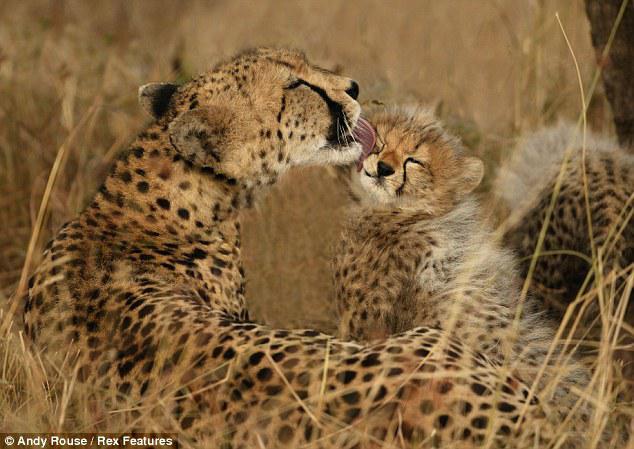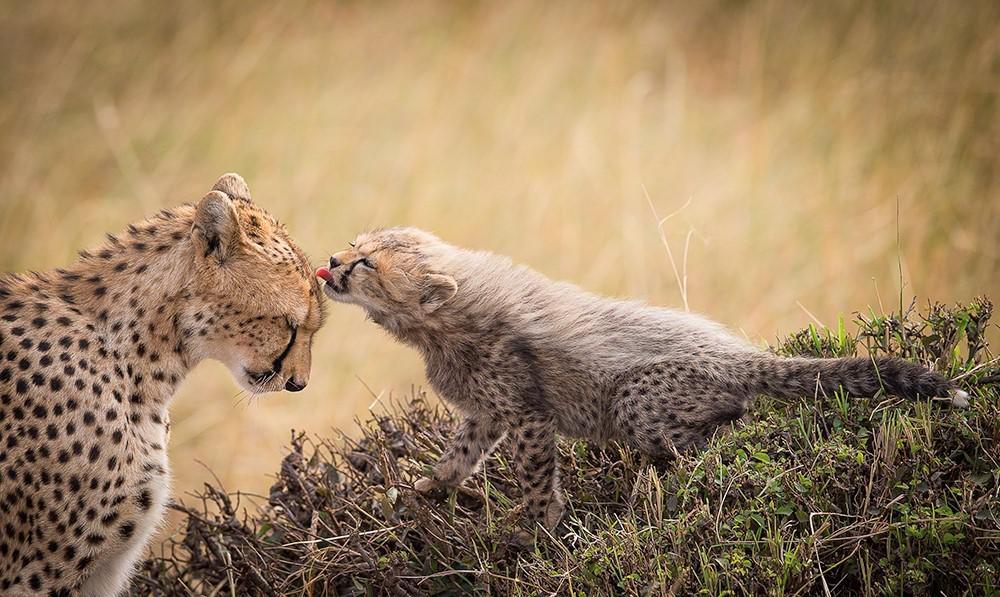The first image is the image on the left, the second image is the image on the right. Examine the images to the left and right. Is the description "There are 4 cheetas in the field." accurate? Answer yes or no. Yes. 